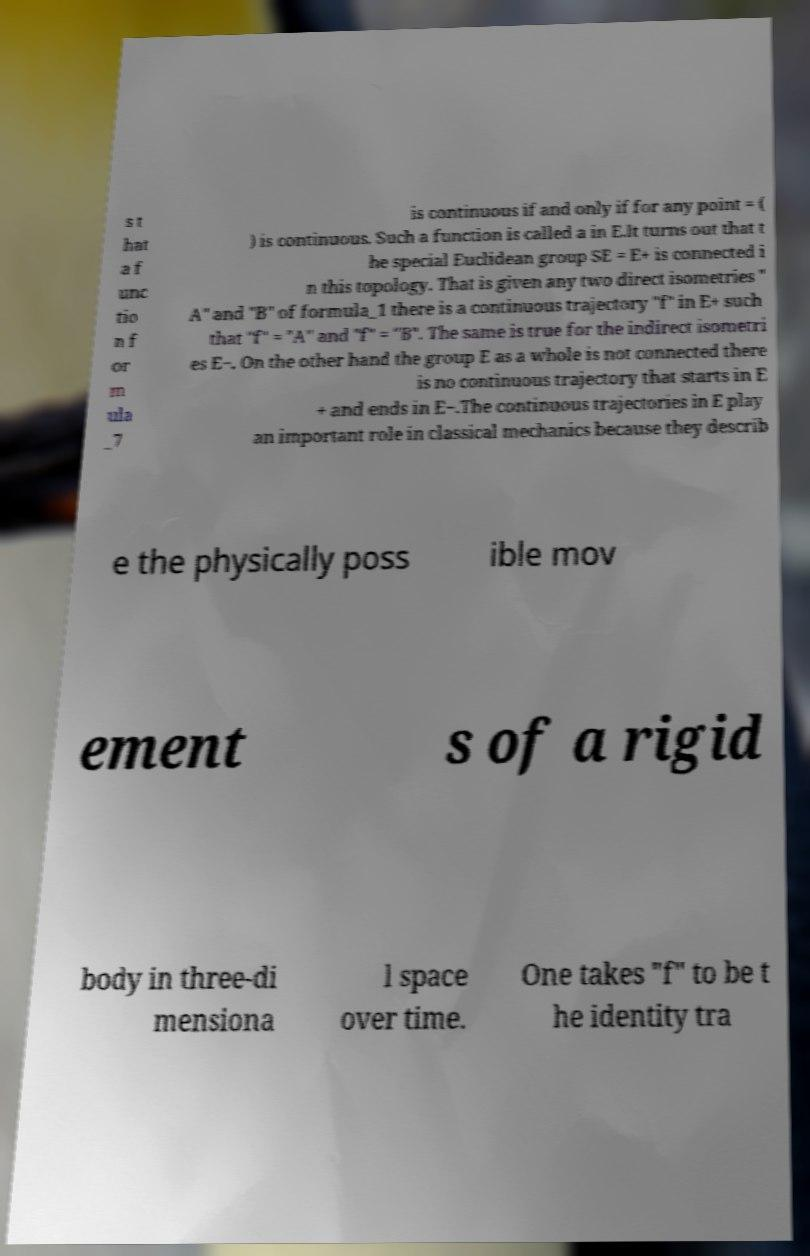Please read and relay the text visible in this image. What does it say? s t hat a f unc tio n f or m ula _7 is continuous if and only if for any point = ( ) is continuous. Such a function is called a in E.It turns out that t he special Euclidean group SE = E+ is connected i n this topology. That is given any two direct isometries " A" and "B" of formula_1 there is a continuous trajectory "f" in E+ such that "f" = "A" and "f" = "B". The same is true for the indirect isometri es E−. On the other hand the group E as a whole is not connected there is no continuous trajectory that starts in E + and ends in E−.The continuous trajectories in E play an important role in classical mechanics because they describ e the physically poss ible mov ement s of a rigid body in three-di mensiona l space over time. One takes "f" to be t he identity tra 